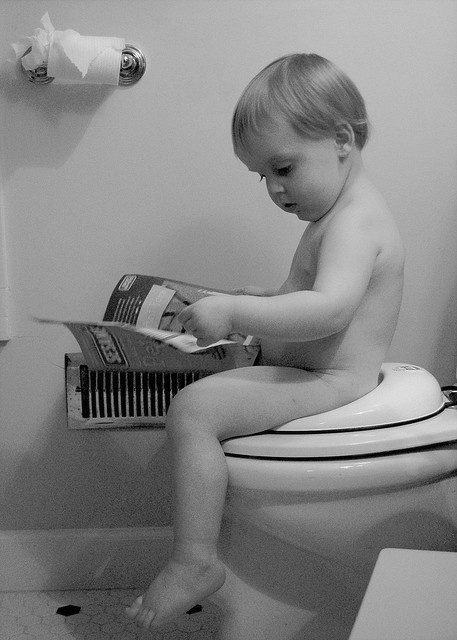Describe the objects in this image and their specific colors. I can see people in darkgray, gray, black, and silver tones, toilet in darkgray, gray, lightgray, and black tones, and book in darkgray, gray, black, and lightgray tones in this image. 